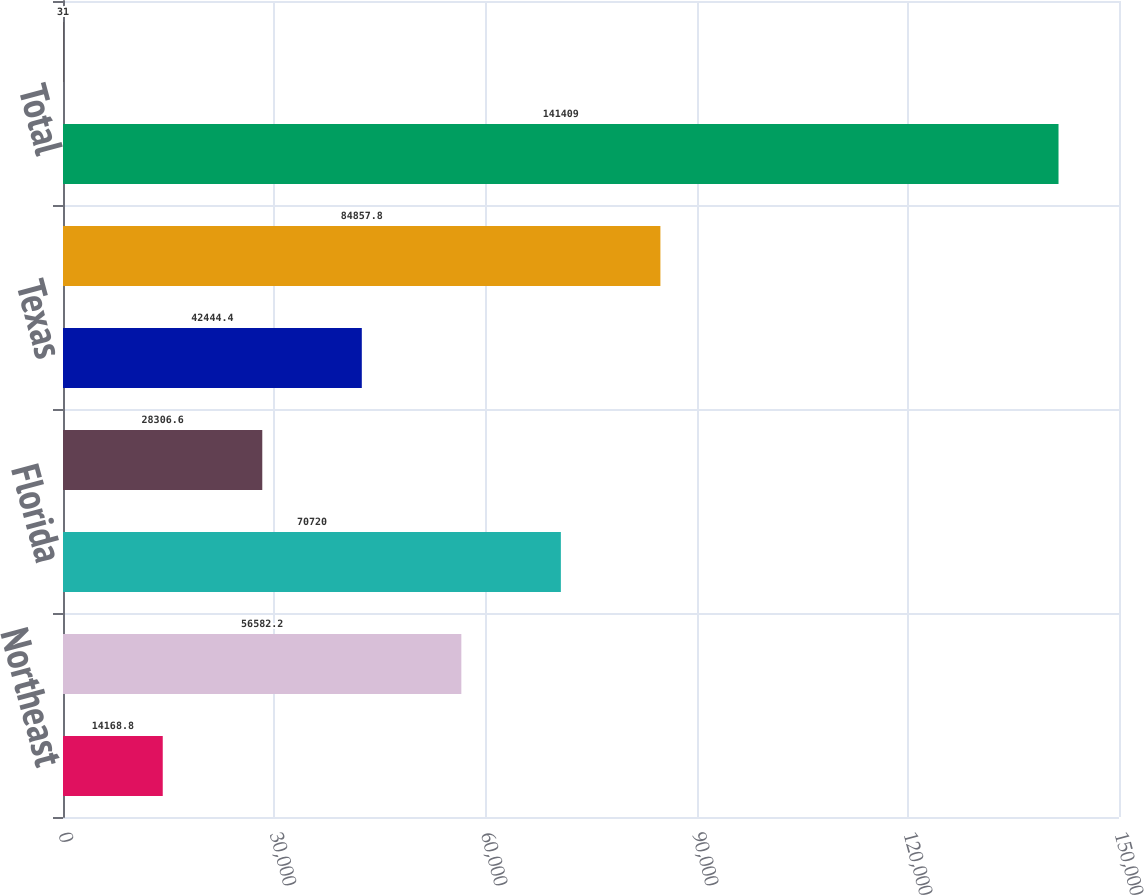<chart> <loc_0><loc_0><loc_500><loc_500><bar_chart><fcel>Northeast<fcel>Southeast<fcel>Florida<fcel>Midwest<fcel>Texas<fcel>West<fcel>Total<fcel>Developed ()<nl><fcel>14168.8<fcel>56582.2<fcel>70720<fcel>28306.6<fcel>42444.4<fcel>84857.8<fcel>141409<fcel>31<nl></chart> 